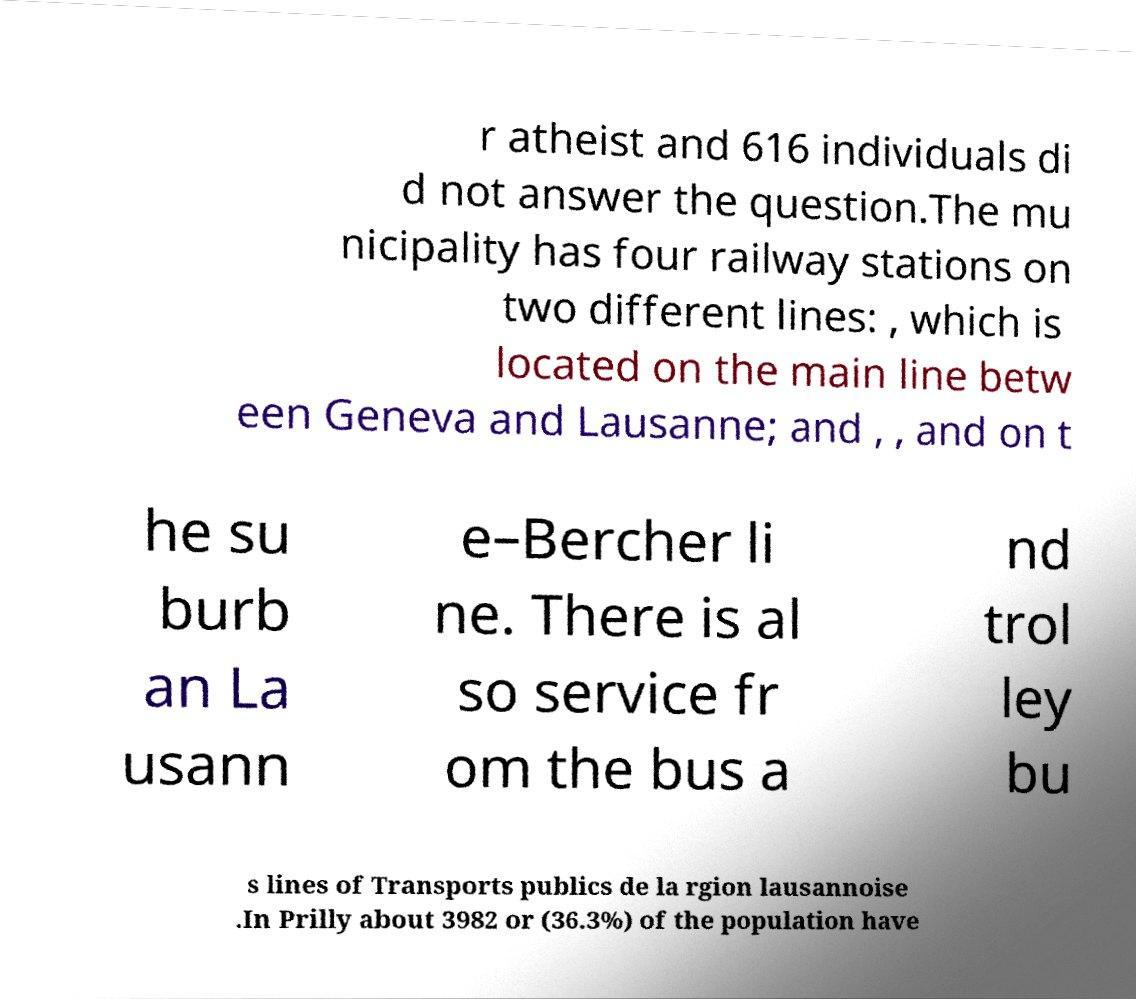Please read and relay the text visible in this image. What does it say? r atheist and 616 individuals di d not answer the question.The mu nicipality has four railway stations on two different lines: , which is located on the main line betw een Geneva and Lausanne; and , , and on t he su burb an La usann e–Bercher li ne. There is al so service fr om the bus a nd trol ley bu s lines of Transports publics de la rgion lausannoise .In Prilly about 3982 or (36.3%) of the population have 